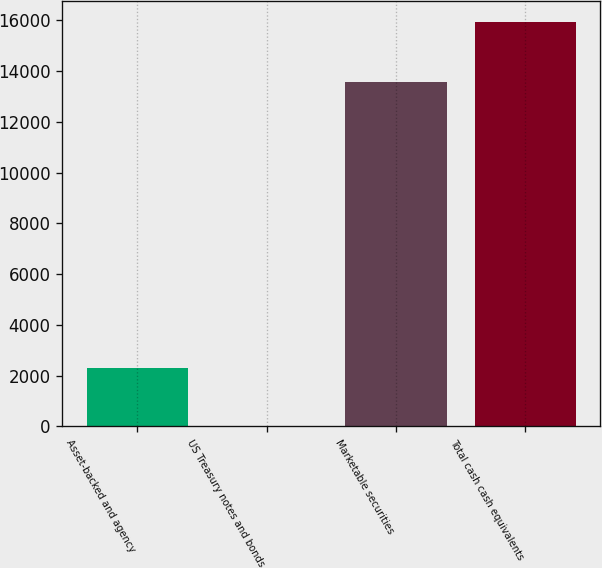<chart> <loc_0><loc_0><loc_500><loc_500><bar_chart><fcel>Asset-backed and agency<fcel>US Treasury notes and bonds<fcel>Marketable securities<fcel>Total cash cash equivalents<nl><fcel>2311<fcel>3<fcel>13549<fcel>15943<nl></chart> 